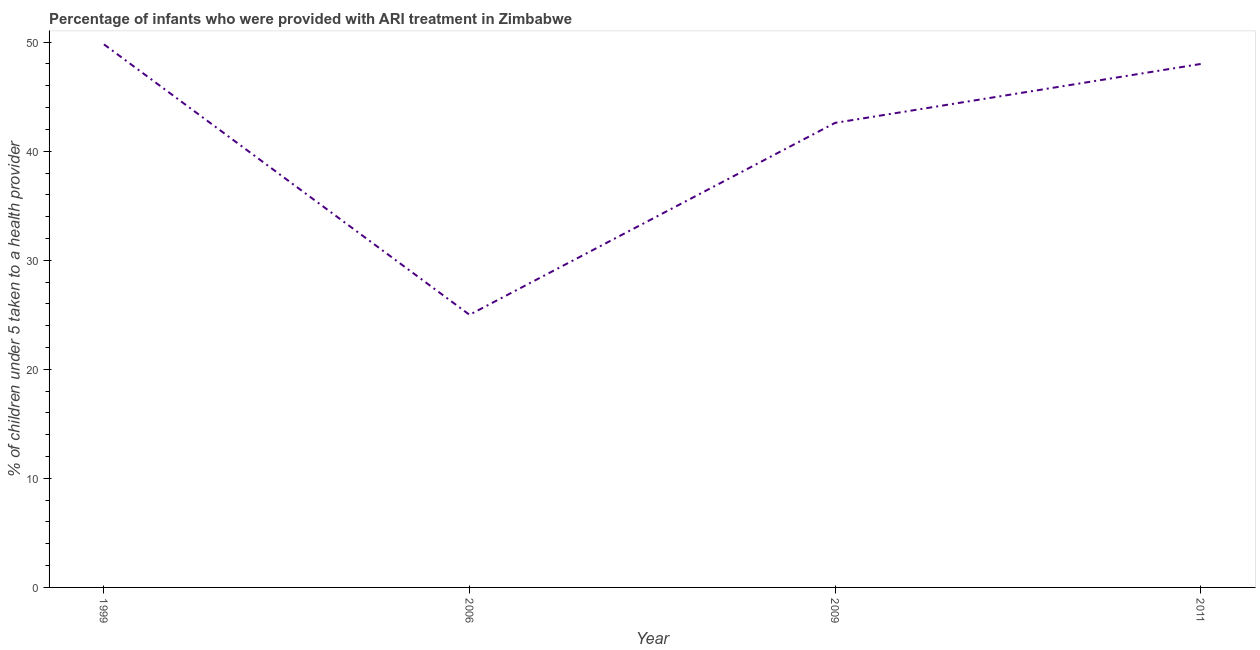Across all years, what is the maximum percentage of children who were provided with ari treatment?
Your answer should be very brief. 49.8. In which year was the percentage of children who were provided with ari treatment maximum?
Make the answer very short. 1999. In which year was the percentage of children who were provided with ari treatment minimum?
Give a very brief answer. 2006. What is the sum of the percentage of children who were provided with ari treatment?
Offer a terse response. 165.4. What is the difference between the percentage of children who were provided with ari treatment in 1999 and 2006?
Give a very brief answer. 24.8. What is the average percentage of children who were provided with ari treatment per year?
Your answer should be very brief. 41.35. What is the median percentage of children who were provided with ari treatment?
Provide a succinct answer. 45.3. What is the ratio of the percentage of children who were provided with ari treatment in 1999 to that in 2006?
Your answer should be compact. 1.99. Is the difference between the percentage of children who were provided with ari treatment in 2006 and 2009 greater than the difference between any two years?
Your response must be concise. No. What is the difference between the highest and the second highest percentage of children who were provided with ari treatment?
Your answer should be very brief. 1.8. What is the difference between the highest and the lowest percentage of children who were provided with ari treatment?
Offer a terse response. 24.8. In how many years, is the percentage of children who were provided with ari treatment greater than the average percentage of children who were provided with ari treatment taken over all years?
Provide a succinct answer. 3. How many years are there in the graph?
Your answer should be compact. 4. Does the graph contain grids?
Your answer should be very brief. No. What is the title of the graph?
Provide a succinct answer. Percentage of infants who were provided with ARI treatment in Zimbabwe. What is the label or title of the X-axis?
Offer a very short reply. Year. What is the label or title of the Y-axis?
Provide a succinct answer. % of children under 5 taken to a health provider. What is the % of children under 5 taken to a health provider of 1999?
Make the answer very short. 49.8. What is the % of children under 5 taken to a health provider in 2009?
Offer a terse response. 42.6. What is the difference between the % of children under 5 taken to a health provider in 1999 and 2006?
Offer a very short reply. 24.8. What is the difference between the % of children under 5 taken to a health provider in 1999 and 2009?
Provide a succinct answer. 7.2. What is the difference between the % of children under 5 taken to a health provider in 2006 and 2009?
Offer a very short reply. -17.6. What is the difference between the % of children under 5 taken to a health provider in 2006 and 2011?
Offer a very short reply. -23. What is the ratio of the % of children under 5 taken to a health provider in 1999 to that in 2006?
Ensure brevity in your answer.  1.99. What is the ratio of the % of children under 5 taken to a health provider in 1999 to that in 2009?
Your answer should be very brief. 1.17. What is the ratio of the % of children under 5 taken to a health provider in 1999 to that in 2011?
Ensure brevity in your answer.  1.04. What is the ratio of the % of children under 5 taken to a health provider in 2006 to that in 2009?
Provide a succinct answer. 0.59. What is the ratio of the % of children under 5 taken to a health provider in 2006 to that in 2011?
Make the answer very short. 0.52. What is the ratio of the % of children under 5 taken to a health provider in 2009 to that in 2011?
Provide a succinct answer. 0.89. 